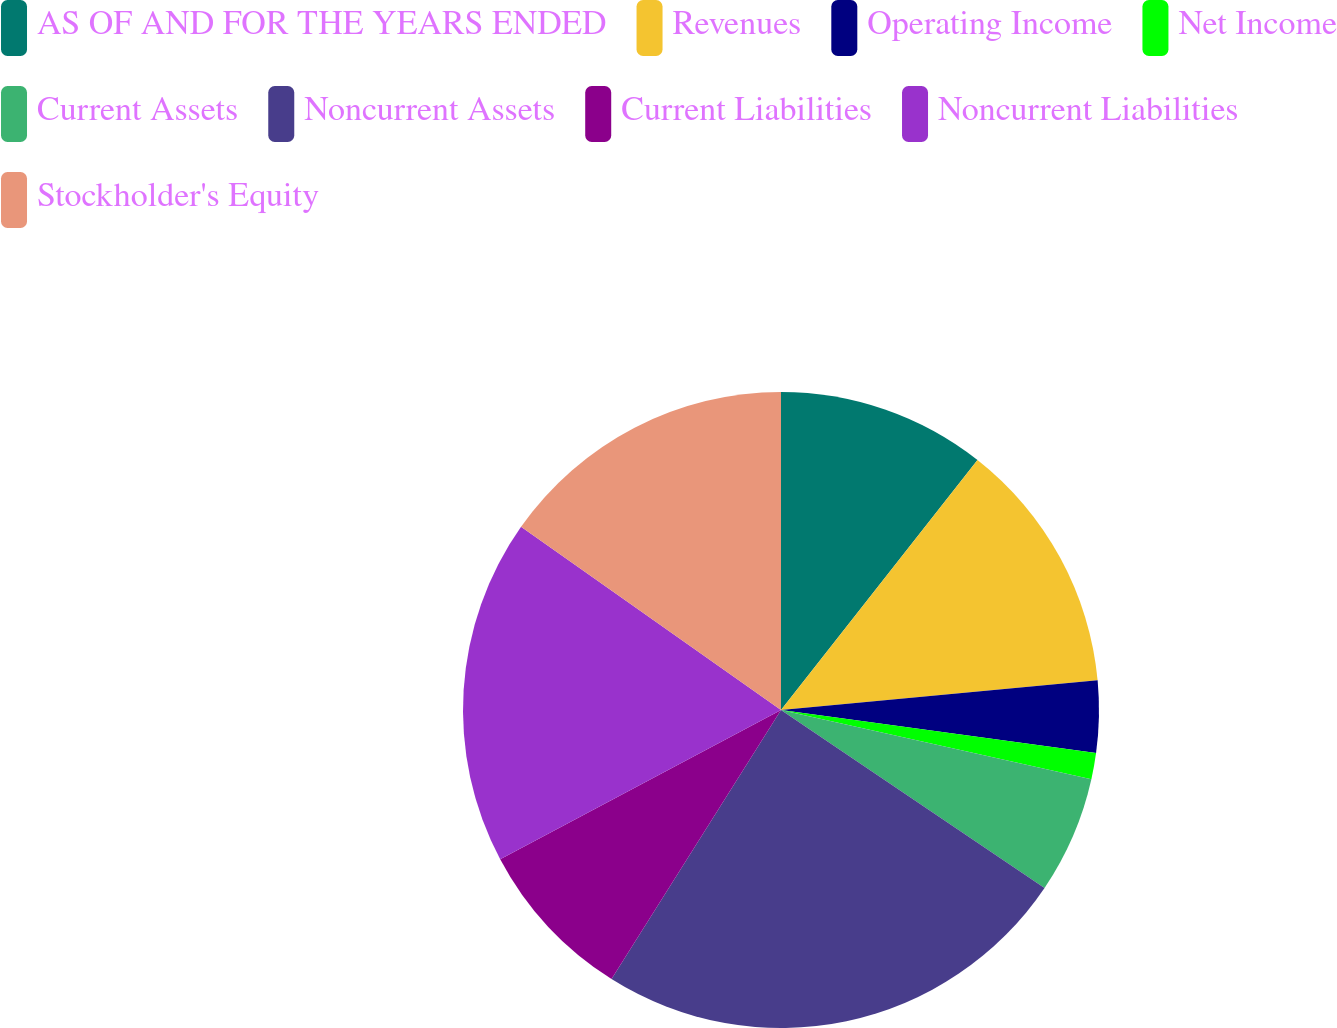Convert chart to OTSL. <chart><loc_0><loc_0><loc_500><loc_500><pie_chart><fcel>AS OF AND FOR THE YEARS ENDED<fcel>Revenues<fcel>Operating Income<fcel>Net Income<fcel>Current Assets<fcel>Noncurrent Assets<fcel>Current Liabilities<fcel>Noncurrent Liabilities<fcel>Stockholder's Equity<nl><fcel>10.6%<fcel>12.91%<fcel>3.65%<fcel>1.33%<fcel>5.96%<fcel>24.49%<fcel>8.28%<fcel>17.54%<fcel>15.23%<nl></chart> 